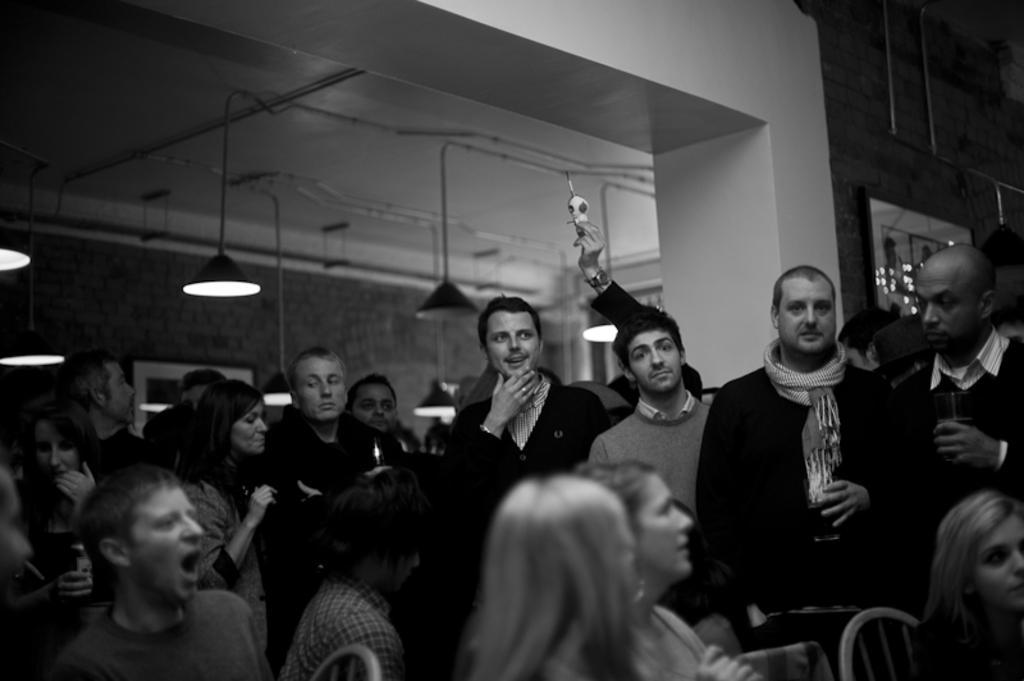Could you give a brief overview of what you see in this image? This is the picture of a black and white image and we can see some people in a room and there is a wall with a photo frame. We can see few lights attached to the ceiling. 